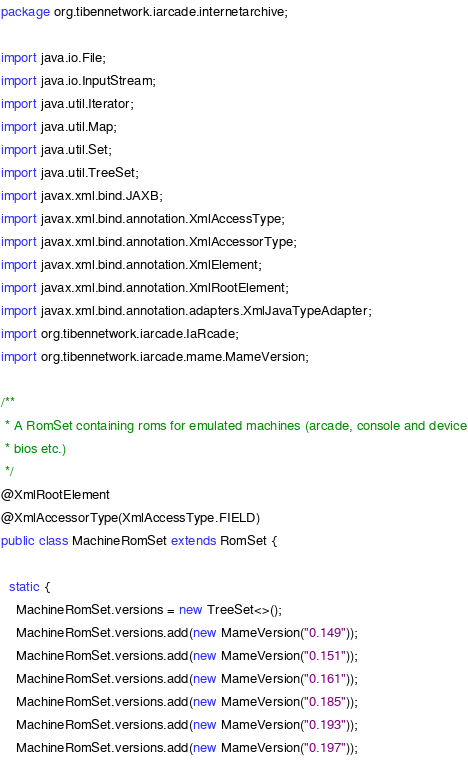Convert code to text. <code><loc_0><loc_0><loc_500><loc_500><_Java_>package org.tibennetwork.iarcade.internetarchive;

import java.io.File;
import java.io.InputStream;
import java.util.Iterator;
import java.util.Map;
import java.util.Set;
import java.util.TreeSet;
import javax.xml.bind.JAXB;
import javax.xml.bind.annotation.XmlAccessType;
import javax.xml.bind.annotation.XmlAccessorType;
import javax.xml.bind.annotation.XmlElement;
import javax.xml.bind.annotation.XmlRootElement;
import javax.xml.bind.annotation.adapters.XmlJavaTypeAdapter;
import org.tibennetwork.iarcade.IaRcade;
import org.tibennetwork.iarcade.mame.MameVersion;

/**
 * A RomSet containing roms for emulated machines (arcade, console and device
 * bios etc.)
 */
@XmlRootElement
@XmlAccessorType(XmlAccessType.FIELD)
public class MachineRomSet extends RomSet {

  static {
    MachineRomSet.versions = new TreeSet<>();
    MachineRomSet.versions.add(new MameVersion("0.149"));
    MachineRomSet.versions.add(new MameVersion("0.151"));
    MachineRomSet.versions.add(new MameVersion("0.161"));
    MachineRomSet.versions.add(new MameVersion("0.185"));
    MachineRomSet.versions.add(new MameVersion("0.193"));
    MachineRomSet.versions.add(new MameVersion("0.197"));</code> 